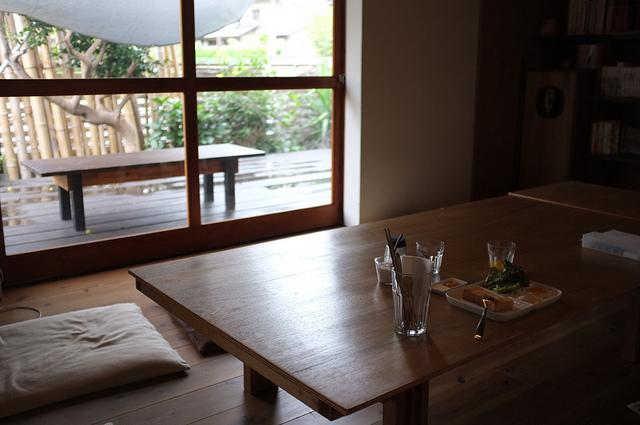What is closest to the left ledge of the table? glass 